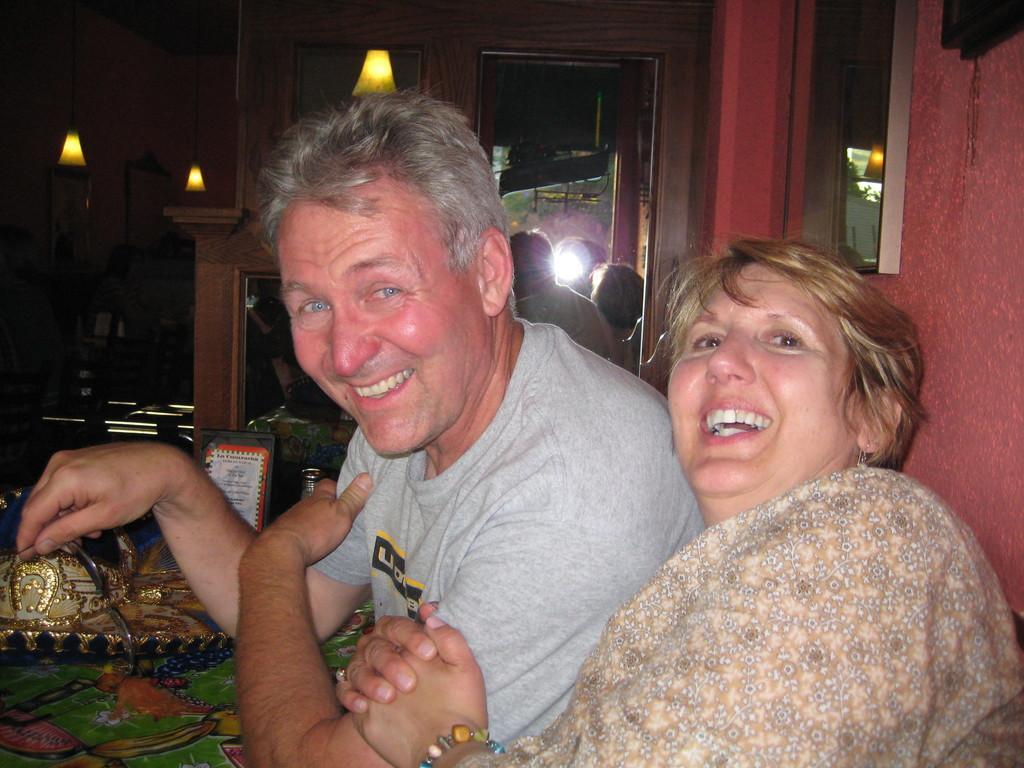Describe this image in one or two sentences. In this image I can see two persons in front of a table on which some objects are placed. In the background I can see a wall, door, window, lamps, group of people and dark color. This image is taken may be in a room. 